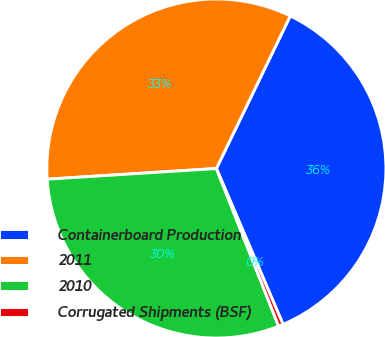Convert chart. <chart><loc_0><loc_0><loc_500><loc_500><pie_chart><fcel>Containerboard Production<fcel>2011<fcel>2010<fcel>Corrugated Shipments (BSF)<nl><fcel>36.39%<fcel>33.18%<fcel>29.98%<fcel>0.45%<nl></chart> 